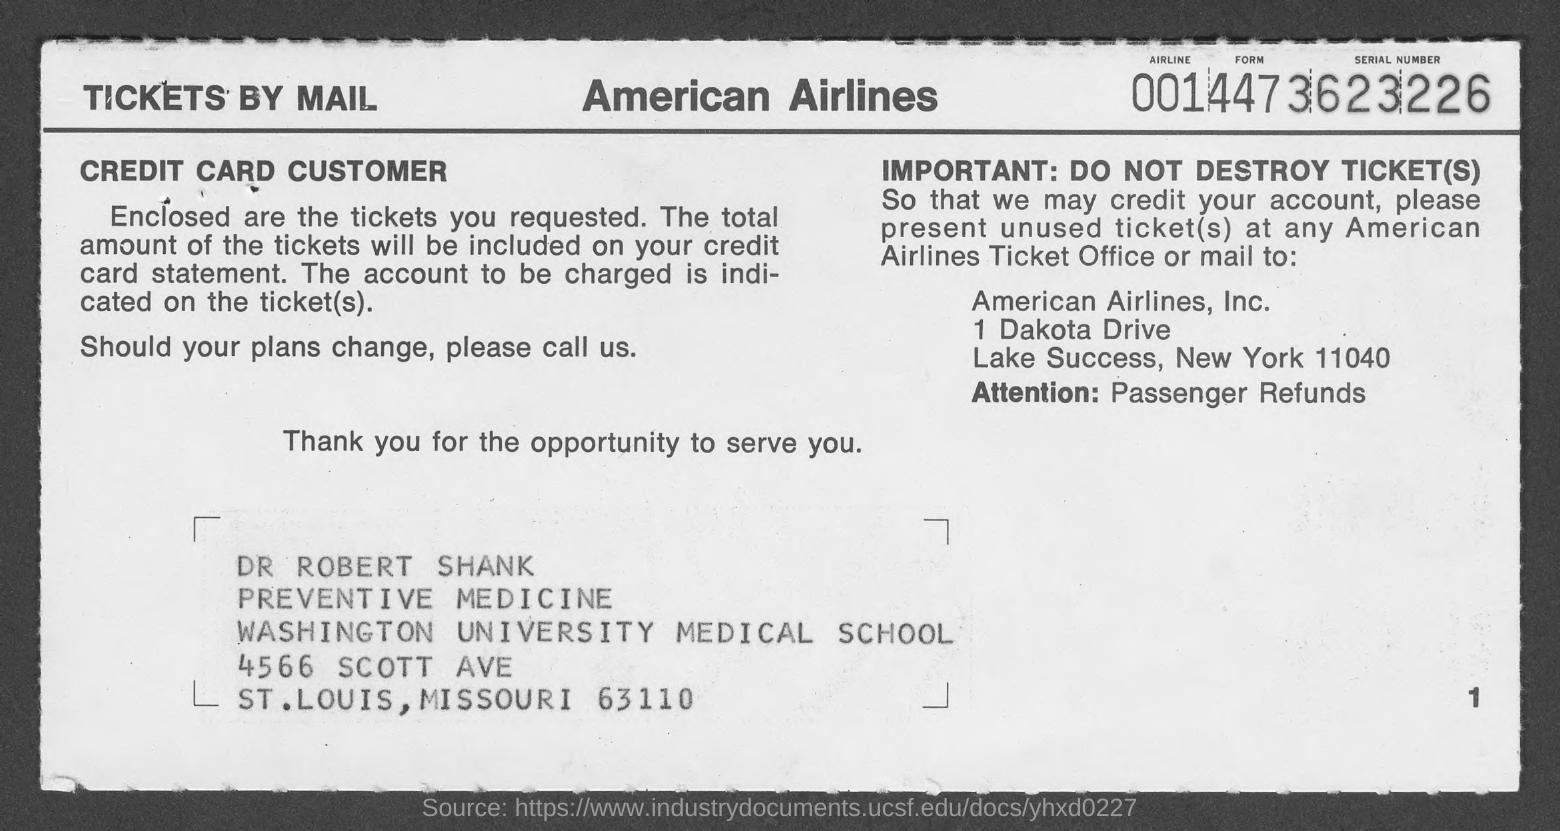Give some essential details in this illustration. The Airline Form Serial Number is 0014473623226... The letter is addressed to Dr. Robert Shank. 